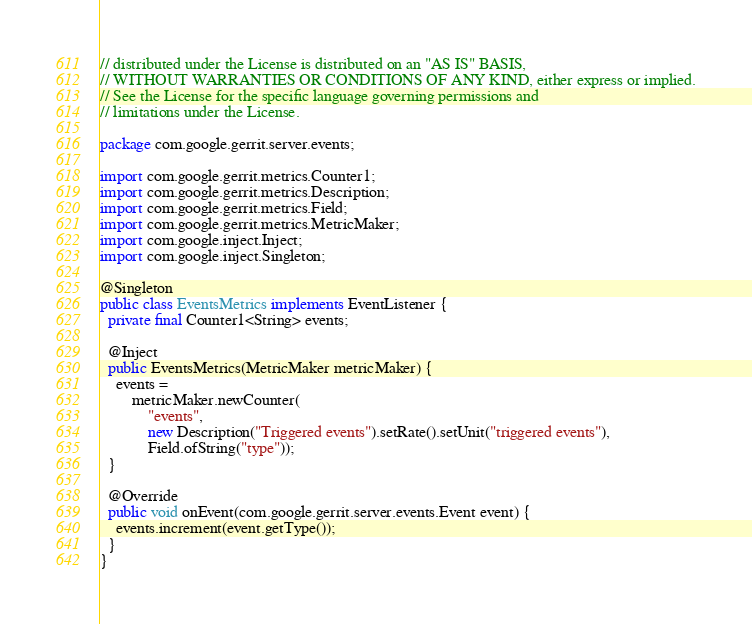Convert code to text. <code><loc_0><loc_0><loc_500><loc_500><_Java_>// distributed under the License is distributed on an "AS IS" BASIS,
// WITHOUT WARRANTIES OR CONDITIONS OF ANY KIND, either express or implied.
// See the License for the specific language governing permissions and
// limitations under the License.

package com.google.gerrit.server.events;

import com.google.gerrit.metrics.Counter1;
import com.google.gerrit.metrics.Description;
import com.google.gerrit.metrics.Field;
import com.google.gerrit.metrics.MetricMaker;
import com.google.inject.Inject;
import com.google.inject.Singleton;

@Singleton
public class EventsMetrics implements EventListener {
  private final Counter1<String> events;

  @Inject
  public EventsMetrics(MetricMaker metricMaker) {
    events =
        metricMaker.newCounter(
            "events",
            new Description("Triggered events").setRate().setUnit("triggered events"),
            Field.ofString("type"));
  }

  @Override
  public void onEvent(com.google.gerrit.server.events.Event event) {
    events.increment(event.getType());
  }
}
</code> 